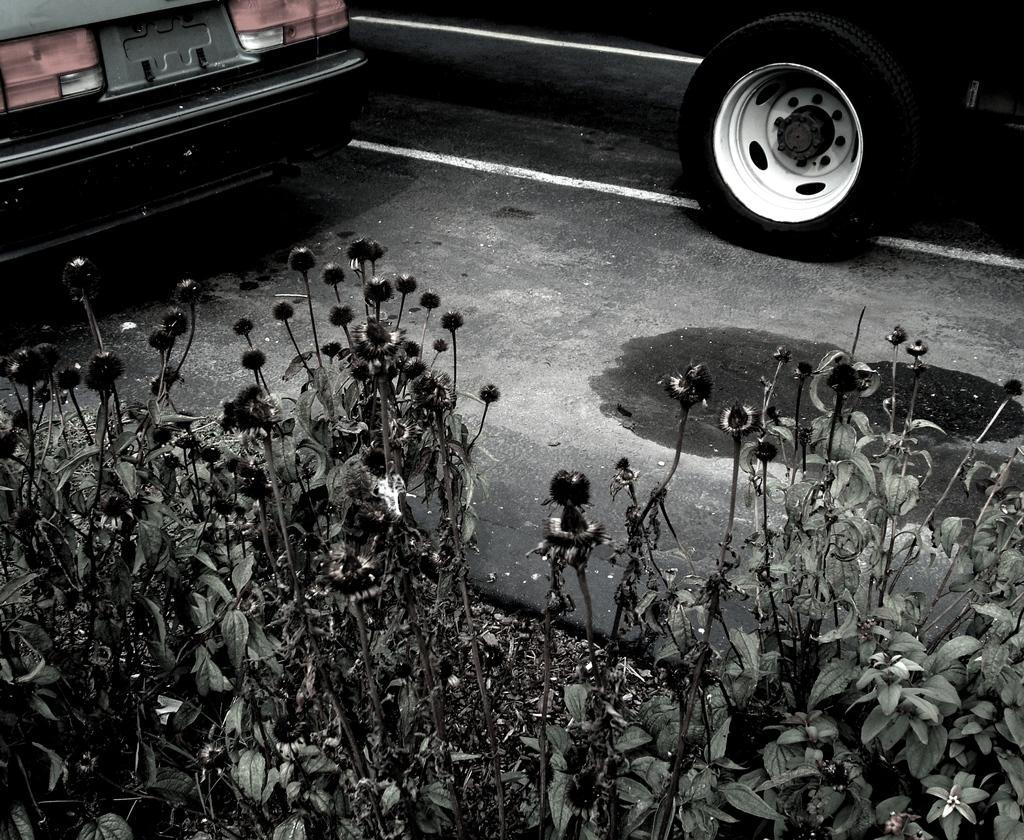Could you give a brief overview of what you see in this image? In the foreground I can see plants and vehicles on the road. This image is taken during night on the road. 